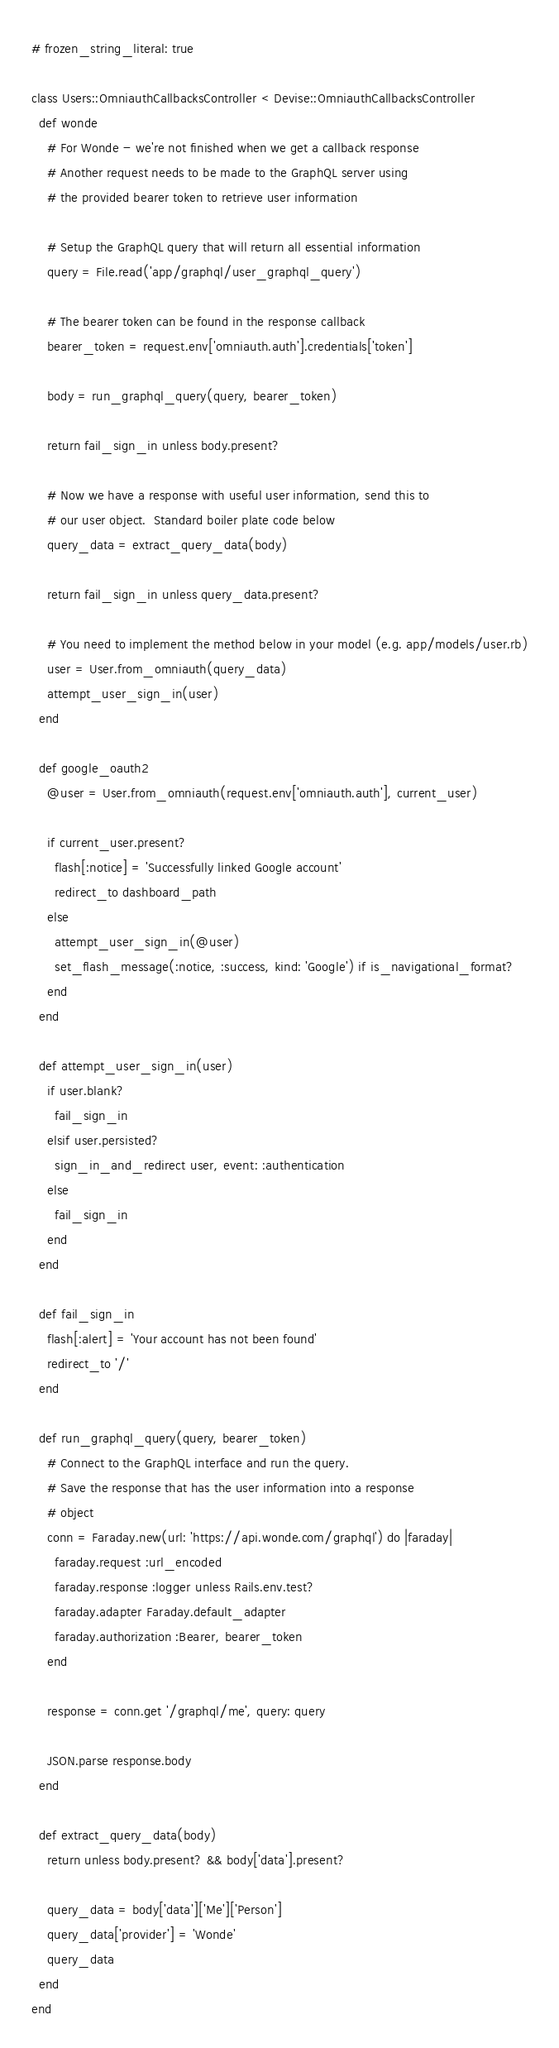<code> <loc_0><loc_0><loc_500><loc_500><_Ruby_># frozen_string_literal: true

class Users::OmniauthCallbacksController < Devise::OmniauthCallbacksController
  def wonde
    # For Wonde - we're not finished when we get a callback response
    # Another request needs to be made to the GraphQL server using
    # the provided bearer token to retrieve user information

    # Setup the GraphQL query that will return all essential information
    query = File.read('app/graphql/user_graphql_query')

    # The bearer token can be found in the response callback
    bearer_token = request.env['omniauth.auth'].credentials['token']

    body = run_graphql_query(query, bearer_token)

    return fail_sign_in unless body.present?

    # Now we have a response with useful user information, send this to
    # our user object.  Standard boiler plate code below
    query_data = extract_query_data(body)

    return fail_sign_in unless query_data.present?

    # You need to implement the method below in your model (e.g. app/models/user.rb)
    user = User.from_omniauth(query_data)
    attempt_user_sign_in(user)
  end

  def google_oauth2
    @user = User.from_omniauth(request.env['omniauth.auth'], current_user)

    if current_user.present?
      flash[:notice] = 'Successfully linked Google account'
      redirect_to dashboard_path
    else
      attempt_user_sign_in(@user)
      set_flash_message(:notice, :success, kind: 'Google') if is_navigational_format?
    end
  end

  def attempt_user_sign_in(user)
    if user.blank?
      fail_sign_in
    elsif user.persisted?
      sign_in_and_redirect user, event: :authentication
    else
      fail_sign_in
    end
  end

  def fail_sign_in
    flash[:alert] = 'Your account has not been found'
    redirect_to '/'
  end

  def run_graphql_query(query, bearer_token)
    # Connect to the GraphQL interface and run the query.
    # Save the response that has the user information into a response
    # object
    conn = Faraday.new(url: 'https://api.wonde.com/graphql') do |faraday|
      faraday.request :url_encoded
      faraday.response :logger unless Rails.env.test?
      faraday.adapter Faraday.default_adapter
      faraday.authorization :Bearer, bearer_token
    end

    response = conn.get '/graphql/me', query: query

    JSON.parse response.body
  end

  def extract_query_data(body)
    return unless body.present? && body['data'].present?

    query_data = body['data']['Me']['Person']
    query_data['provider'] = 'Wonde'
    query_data
  end
end
</code> 